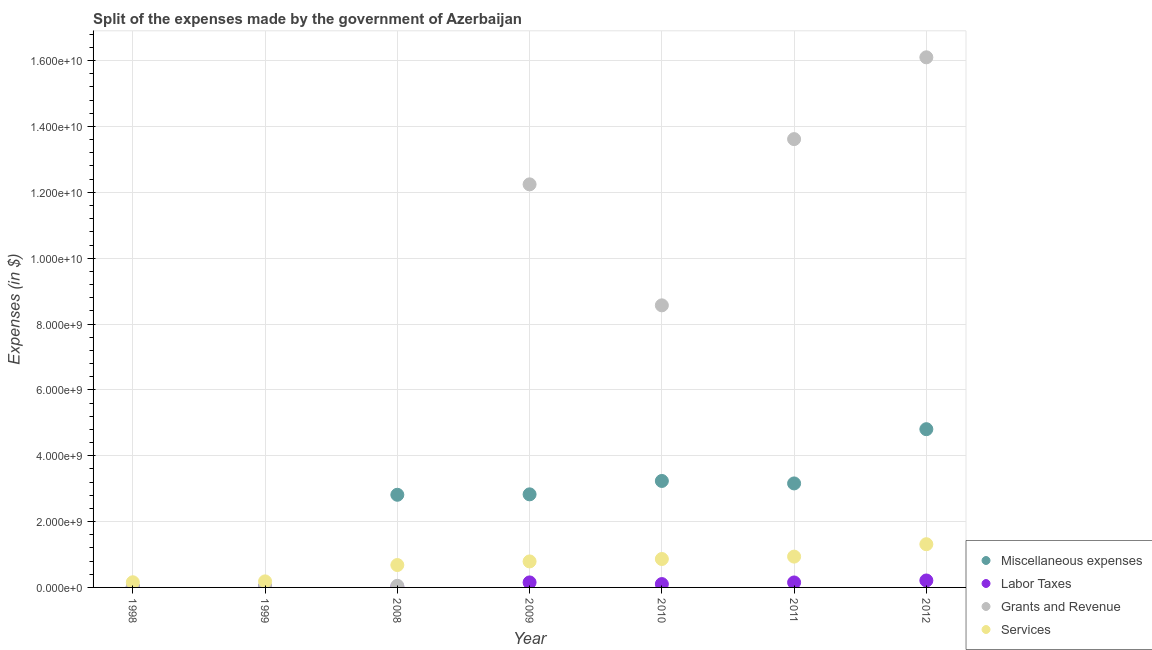What is the amount spent on miscellaneous expenses in 2011?
Offer a very short reply. 3.16e+09. Across all years, what is the maximum amount spent on services?
Your response must be concise. 1.31e+09. Across all years, what is the minimum amount spent on services?
Provide a succinct answer. 1.57e+08. In which year was the amount spent on labor taxes minimum?
Offer a terse response. 1998. What is the total amount spent on labor taxes in the graph?
Make the answer very short. 6.56e+08. What is the difference between the amount spent on services in 1998 and that in 2008?
Give a very brief answer. -5.24e+08. What is the difference between the amount spent on labor taxes in 2011 and the amount spent on grants and revenue in 1998?
Offer a terse response. 1.18e+08. What is the average amount spent on labor taxes per year?
Keep it short and to the point. 9.37e+07. In the year 1998, what is the difference between the amount spent on labor taxes and amount spent on grants and revenue?
Provide a succinct answer. -2.40e+07. What is the ratio of the amount spent on labor taxes in 2008 to that in 2010?
Give a very brief answer. 0.14. Is the difference between the amount spent on services in 2011 and 2012 greater than the difference between the amount spent on grants and revenue in 2011 and 2012?
Give a very brief answer. Yes. What is the difference between the highest and the second highest amount spent on labor taxes?
Provide a succinct answer. 5.88e+07. What is the difference between the highest and the lowest amount spent on miscellaneous expenses?
Your answer should be compact. 4.79e+09. In how many years, is the amount spent on grants and revenue greater than the average amount spent on grants and revenue taken over all years?
Make the answer very short. 4. Is the amount spent on labor taxes strictly greater than the amount spent on services over the years?
Ensure brevity in your answer.  No. How many dotlines are there?
Give a very brief answer. 4. How many years are there in the graph?
Keep it short and to the point. 7. What is the difference between two consecutive major ticks on the Y-axis?
Give a very brief answer. 2.00e+09. Where does the legend appear in the graph?
Offer a very short reply. Bottom right. How are the legend labels stacked?
Offer a very short reply. Vertical. What is the title of the graph?
Keep it short and to the point. Split of the expenses made by the government of Azerbaijan. What is the label or title of the X-axis?
Make the answer very short. Year. What is the label or title of the Y-axis?
Offer a very short reply. Expenses (in $). What is the Expenses (in $) of Miscellaneous expenses in 1998?
Provide a succinct answer. 1.60e+07. What is the Expenses (in $) in Labor Taxes in 1998?
Provide a succinct answer. 8.90e+06. What is the Expenses (in $) in Grants and Revenue in 1998?
Your answer should be very brief. 3.29e+07. What is the Expenses (in $) of Services in 1998?
Keep it short and to the point. 1.57e+08. What is the Expenses (in $) of Miscellaneous expenses in 1999?
Provide a succinct answer. 1.23e+07. What is the Expenses (in $) of Labor Taxes in 1999?
Your response must be concise. 1.66e+07. What is the Expenses (in $) of Grants and Revenue in 1999?
Keep it short and to the point. 4.76e+07. What is the Expenses (in $) in Services in 1999?
Keep it short and to the point. 1.84e+08. What is the Expenses (in $) in Miscellaneous expenses in 2008?
Keep it short and to the point. 2.81e+09. What is the Expenses (in $) of Labor Taxes in 2008?
Offer a very short reply. 1.43e+07. What is the Expenses (in $) of Grants and Revenue in 2008?
Your answer should be very brief. 4.87e+07. What is the Expenses (in $) in Services in 2008?
Make the answer very short. 6.80e+08. What is the Expenses (in $) of Miscellaneous expenses in 2009?
Offer a terse response. 2.83e+09. What is the Expenses (in $) in Labor Taxes in 2009?
Provide a short and direct response. 1.52e+08. What is the Expenses (in $) in Grants and Revenue in 2009?
Keep it short and to the point. 1.22e+1. What is the Expenses (in $) of Services in 2009?
Provide a short and direct response. 7.90e+08. What is the Expenses (in $) of Miscellaneous expenses in 2010?
Provide a succinct answer. 3.23e+09. What is the Expenses (in $) in Labor Taxes in 2010?
Offer a terse response. 1.02e+08. What is the Expenses (in $) in Grants and Revenue in 2010?
Provide a short and direct response. 8.57e+09. What is the Expenses (in $) in Services in 2010?
Offer a terse response. 8.63e+08. What is the Expenses (in $) in Miscellaneous expenses in 2011?
Provide a succinct answer. 3.16e+09. What is the Expenses (in $) of Labor Taxes in 2011?
Your answer should be very brief. 1.51e+08. What is the Expenses (in $) in Grants and Revenue in 2011?
Your response must be concise. 1.36e+1. What is the Expenses (in $) of Services in 2011?
Offer a very short reply. 9.36e+08. What is the Expenses (in $) in Miscellaneous expenses in 2012?
Offer a very short reply. 4.81e+09. What is the Expenses (in $) in Labor Taxes in 2012?
Ensure brevity in your answer.  2.11e+08. What is the Expenses (in $) of Grants and Revenue in 2012?
Keep it short and to the point. 1.61e+1. What is the Expenses (in $) in Services in 2012?
Provide a short and direct response. 1.31e+09. Across all years, what is the maximum Expenses (in $) of Miscellaneous expenses?
Your answer should be compact. 4.81e+09. Across all years, what is the maximum Expenses (in $) in Labor Taxes?
Offer a very short reply. 2.11e+08. Across all years, what is the maximum Expenses (in $) of Grants and Revenue?
Offer a very short reply. 1.61e+1. Across all years, what is the maximum Expenses (in $) of Services?
Ensure brevity in your answer.  1.31e+09. Across all years, what is the minimum Expenses (in $) of Miscellaneous expenses?
Your answer should be very brief. 1.23e+07. Across all years, what is the minimum Expenses (in $) in Labor Taxes?
Keep it short and to the point. 8.90e+06. Across all years, what is the minimum Expenses (in $) of Grants and Revenue?
Your response must be concise. 3.29e+07. Across all years, what is the minimum Expenses (in $) of Services?
Ensure brevity in your answer.  1.57e+08. What is the total Expenses (in $) in Miscellaneous expenses in the graph?
Give a very brief answer. 1.69e+1. What is the total Expenses (in $) of Labor Taxes in the graph?
Your response must be concise. 6.56e+08. What is the total Expenses (in $) in Grants and Revenue in the graph?
Provide a succinct answer. 5.07e+1. What is the total Expenses (in $) of Services in the graph?
Your response must be concise. 4.92e+09. What is the difference between the Expenses (in $) in Miscellaneous expenses in 1998 and that in 1999?
Provide a short and direct response. 3.77e+06. What is the difference between the Expenses (in $) in Labor Taxes in 1998 and that in 1999?
Keep it short and to the point. -7.72e+06. What is the difference between the Expenses (in $) of Grants and Revenue in 1998 and that in 1999?
Ensure brevity in your answer.  -1.47e+07. What is the difference between the Expenses (in $) of Services in 1998 and that in 1999?
Give a very brief answer. -2.69e+07. What is the difference between the Expenses (in $) of Miscellaneous expenses in 1998 and that in 2008?
Your response must be concise. -2.80e+09. What is the difference between the Expenses (in $) of Labor Taxes in 1998 and that in 2008?
Your answer should be compact. -5.36e+06. What is the difference between the Expenses (in $) of Grants and Revenue in 1998 and that in 2008?
Offer a very short reply. -1.58e+07. What is the difference between the Expenses (in $) in Services in 1998 and that in 2008?
Give a very brief answer. -5.24e+08. What is the difference between the Expenses (in $) in Miscellaneous expenses in 1998 and that in 2009?
Provide a short and direct response. -2.81e+09. What is the difference between the Expenses (in $) of Labor Taxes in 1998 and that in 2009?
Make the answer very short. -1.43e+08. What is the difference between the Expenses (in $) of Grants and Revenue in 1998 and that in 2009?
Your answer should be very brief. -1.22e+1. What is the difference between the Expenses (in $) of Services in 1998 and that in 2009?
Your answer should be compact. -6.33e+08. What is the difference between the Expenses (in $) of Miscellaneous expenses in 1998 and that in 2010?
Make the answer very short. -3.22e+09. What is the difference between the Expenses (in $) of Labor Taxes in 1998 and that in 2010?
Your answer should be very brief. -9.28e+07. What is the difference between the Expenses (in $) of Grants and Revenue in 1998 and that in 2010?
Keep it short and to the point. -8.53e+09. What is the difference between the Expenses (in $) of Services in 1998 and that in 2010?
Offer a terse response. -7.06e+08. What is the difference between the Expenses (in $) in Miscellaneous expenses in 1998 and that in 2011?
Provide a short and direct response. -3.14e+09. What is the difference between the Expenses (in $) in Labor Taxes in 1998 and that in 2011?
Your response must be concise. -1.42e+08. What is the difference between the Expenses (in $) of Grants and Revenue in 1998 and that in 2011?
Provide a succinct answer. -1.36e+1. What is the difference between the Expenses (in $) in Services in 1998 and that in 2011?
Your answer should be very brief. -7.79e+08. What is the difference between the Expenses (in $) in Miscellaneous expenses in 1998 and that in 2012?
Offer a terse response. -4.79e+09. What is the difference between the Expenses (in $) of Labor Taxes in 1998 and that in 2012?
Your response must be concise. -2.02e+08. What is the difference between the Expenses (in $) in Grants and Revenue in 1998 and that in 2012?
Your response must be concise. -1.61e+1. What is the difference between the Expenses (in $) in Services in 1998 and that in 2012?
Give a very brief answer. -1.16e+09. What is the difference between the Expenses (in $) of Miscellaneous expenses in 1999 and that in 2008?
Your answer should be compact. -2.80e+09. What is the difference between the Expenses (in $) in Labor Taxes in 1999 and that in 2008?
Give a very brief answer. 2.36e+06. What is the difference between the Expenses (in $) of Grants and Revenue in 1999 and that in 2008?
Ensure brevity in your answer.  -1.16e+06. What is the difference between the Expenses (in $) in Services in 1999 and that in 2008?
Provide a short and direct response. -4.97e+08. What is the difference between the Expenses (in $) of Miscellaneous expenses in 1999 and that in 2009?
Provide a succinct answer. -2.81e+09. What is the difference between the Expenses (in $) of Labor Taxes in 1999 and that in 2009?
Ensure brevity in your answer.  -1.36e+08. What is the difference between the Expenses (in $) in Grants and Revenue in 1999 and that in 2009?
Give a very brief answer. -1.22e+1. What is the difference between the Expenses (in $) in Services in 1999 and that in 2009?
Offer a terse response. -6.06e+08. What is the difference between the Expenses (in $) in Miscellaneous expenses in 1999 and that in 2010?
Your answer should be compact. -3.22e+09. What is the difference between the Expenses (in $) of Labor Taxes in 1999 and that in 2010?
Provide a short and direct response. -8.51e+07. What is the difference between the Expenses (in $) of Grants and Revenue in 1999 and that in 2010?
Keep it short and to the point. -8.52e+09. What is the difference between the Expenses (in $) of Services in 1999 and that in 2010?
Your answer should be compact. -6.79e+08. What is the difference between the Expenses (in $) of Miscellaneous expenses in 1999 and that in 2011?
Your answer should be compact. -3.15e+09. What is the difference between the Expenses (in $) of Labor Taxes in 1999 and that in 2011?
Provide a short and direct response. -1.34e+08. What is the difference between the Expenses (in $) of Grants and Revenue in 1999 and that in 2011?
Keep it short and to the point. -1.36e+1. What is the difference between the Expenses (in $) in Services in 1999 and that in 2011?
Provide a short and direct response. -7.52e+08. What is the difference between the Expenses (in $) of Miscellaneous expenses in 1999 and that in 2012?
Provide a short and direct response. -4.79e+09. What is the difference between the Expenses (in $) in Labor Taxes in 1999 and that in 2012?
Provide a short and direct response. -1.94e+08. What is the difference between the Expenses (in $) of Grants and Revenue in 1999 and that in 2012?
Keep it short and to the point. -1.61e+1. What is the difference between the Expenses (in $) of Services in 1999 and that in 2012?
Keep it short and to the point. -1.13e+09. What is the difference between the Expenses (in $) in Miscellaneous expenses in 2008 and that in 2009?
Provide a short and direct response. -1.29e+07. What is the difference between the Expenses (in $) of Labor Taxes in 2008 and that in 2009?
Offer a very short reply. -1.38e+08. What is the difference between the Expenses (in $) in Grants and Revenue in 2008 and that in 2009?
Your answer should be very brief. -1.22e+1. What is the difference between the Expenses (in $) of Services in 2008 and that in 2009?
Give a very brief answer. -1.09e+08. What is the difference between the Expenses (in $) of Miscellaneous expenses in 2008 and that in 2010?
Provide a succinct answer. -4.19e+08. What is the difference between the Expenses (in $) of Labor Taxes in 2008 and that in 2010?
Provide a short and direct response. -8.74e+07. What is the difference between the Expenses (in $) of Grants and Revenue in 2008 and that in 2010?
Offer a terse response. -8.52e+09. What is the difference between the Expenses (in $) in Services in 2008 and that in 2010?
Your answer should be very brief. -1.83e+08. What is the difference between the Expenses (in $) of Miscellaneous expenses in 2008 and that in 2011?
Your response must be concise. -3.45e+08. What is the difference between the Expenses (in $) of Labor Taxes in 2008 and that in 2011?
Offer a terse response. -1.37e+08. What is the difference between the Expenses (in $) of Grants and Revenue in 2008 and that in 2011?
Offer a terse response. -1.36e+1. What is the difference between the Expenses (in $) in Services in 2008 and that in 2011?
Keep it short and to the point. -2.56e+08. What is the difference between the Expenses (in $) of Miscellaneous expenses in 2008 and that in 2012?
Your answer should be very brief. -1.99e+09. What is the difference between the Expenses (in $) of Labor Taxes in 2008 and that in 2012?
Your answer should be very brief. -1.97e+08. What is the difference between the Expenses (in $) in Grants and Revenue in 2008 and that in 2012?
Your response must be concise. -1.61e+1. What is the difference between the Expenses (in $) of Services in 2008 and that in 2012?
Keep it short and to the point. -6.32e+08. What is the difference between the Expenses (in $) in Miscellaneous expenses in 2009 and that in 2010?
Give a very brief answer. -4.06e+08. What is the difference between the Expenses (in $) of Labor Taxes in 2009 and that in 2010?
Ensure brevity in your answer.  5.05e+07. What is the difference between the Expenses (in $) in Grants and Revenue in 2009 and that in 2010?
Give a very brief answer. 3.67e+09. What is the difference between the Expenses (in $) of Services in 2009 and that in 2010?
Ensure brevity in your answer.  -7.34e+07. What is the difference between the Expenses (in $) of Miscellaneous expenses in 2009 and that in 2011?
Your answer should be very brief. -3.32e+08. What is the difference between the Expenses (in $) in Labor Taxes in 2009 and that in 2011?
Your answer should be very brief. 1.30e+06. What is the difference between the Expenses (in $) in Grants and Revenue in 2009 and that in 2011?
Provide a short and direct response. -1.37e+09. What is the difference between the Expenses (in $) in Services in 2009 and that in 2011?
Keep it short and to the point. -1.46e+08. What is the difference between the Expenses (in $) of Miscellaneous expenses in 2009 and that in 2012?
Offer a terse response. -1.98e+09. What is the difference between the Expenses (in $) of Labor Taxes in 2009 and that in 2012?
Make the answer very short. -5.88e+07. What is the difference between the Expenses (in $) in Grants and Revenue in 2009 and that in 2012?
Ensure brevity in your answer.  -3.86e+09. What is the difference between the Expenses (in $) in Services in 2009 and that in 2012?
Provide a short and direct response. -5.23e+08. What is the difference between the Expenses (in $) of Miscellaneous expenses in 2010 and that in 2011?
Offer a terse response. 7.48e+07. What is the difference between the Expenses (in $) of Labor Taxes in 2010 and that in 2011?
Offer a terse response. -4.92e+07. What is the difference between the Expenses (in $) of Grants and Revenue in 2010 and that in 2011?
Your response must be concise. -5.05e+09. What is the difference between the Expenses (in $) in Services in 2010 and that in 2011?
Give a very brief answer. -7.29e+07. What is the difference between the Expenses (in $) of Miscellaneous expenses in 2010 and that in 2012?
Ensure brevity in your answer.  -1.57e+09. What is the difference between the Expenses (in $) of Labor Taxes in 2010 and that in 2012?
Ensure brevity in your answer.  -1.09e+08. What is the difference between the Expenses (in $) in Grants and Revenue in 2010 and that in 2012?
Make the answer very short. -7.53e+09. What is the difference between the Expenses (in $) in Services in 2010 and that in 2012?
Keep it short and to the point. -4.49e+08. What is the difference between the Expenses (in $) in Miscellaneous expenses in 2011 and that in 2012?
Ensure brevity in your answer.  -1.65e+09. What is the difference between the Expenses (in $) of Labor Taxes in 2011 and that in 2012?
Make the answer very short. -6.01e+07. What is the difference between the Expenses (in $) of Grants and Revenue in 2011 and that in 2012?
Provide a short and direct response. -2.48e+09. What is the difference between the Expenses (in $) in Services in 2011 and that in 2012?
Provide a succinct answer. -3.76e+08. What is the difference between the Expenses (in $) in Miscellaneous expenses in 1998 and the Expenses (in $) in Labor Taxes in 1999?
Your answer should be very brief. -5.70e+05. What is the difference between the Expenses (in $) of Miscellaneous expenses in 1998 and the Expenses (in $) of Grants and Revenue in 1999?
Your answer should be very brief. -3.15e+07. What is the difference between the Expenses (in $) of Miscellaneous expenses in 1998 and the Expenses (in $) of Services in 1999?
Provide a short and direct response. -1.68e+08. What is the difference between the Expenses (in $) of Labor Taxes in 1998 and the Expenses (in $) of Grants and Revenue in 1999?
Provide a short and direct response. -3.87e+07. What is the difference between the Expenses (in $) in Labor Taxes in 1998 and the Expenses (in $) in Services in 1999?
Make the answer very short. -1.75e+08. What is the difference between the Expenses (in $) in Grants and Revenue in 1998 and the Expenses (in $) in Services in 1999?
Your answer should be very brief. -1.51e+08. What is the difference between the Expenses (in $) of Miscellaneous expenses in 1998 and the Expenses (in $) of Labor Taxes in 2008?
Provide a short and direct response. 1.79e+06. What is the difference between the Expenses (in $) in Miscellaneous expenses in 1998 and the Expenses (in $) in Grants and Revenue in 2008?
Offer a terse response. -3.27e+07. What is the difference between the Expenses (in $) in Miscellaneous expenses in 1998 and the Expenses (in $) in Services in 2008?
Make the answer very short. -6.64e+08. What is the difference between the Expenses (in $) of Labor Taxes in 1998 and the Expenses (in $) of Grants and Revenue in 2008?
Your answer should be compact. -3.98e+07. What is the difference between the Expenses (in $) in Labor Taxes in 1998 and the Expenses (in $) in Services in 2008?
Keep it short and to the point. -6.72e+08. What is the difference between the Expenses (in $) of Grants and Revenue in 1998 and the Expenses (in $) of Services in 2008?
Provide a succinct answer. -6.48e+08. What is the difference between the Expenses (in $) in Miscellaneous expenses in 1998 and the Expenses (in $) in Labor Taxes in 2009?
Keep it short and to the point. -1.36e+08. What is the difference between the Expenses (in $) in Miscellaneous expenses in 1998 and the Expenses (in $) in Grants and Revenue in 2009?
Provide a short and direct response. -1.22e+1. What is the difference between the Expenses (in $) of Miscellaneous expenses in 1998 and the Expenses (in $) of Services in 2009?
Keep it short and to the point. -7.74e+08. What is the difference between the Expenses (in $) of Labor Taxes in 1998 and the Expenses (in $) of Grants and Revenue in 2009?
Offer a terse response. -1.22e+1. What is the difference between the Expenses (in $) in Labor Taxes in 1998 and the Expenses (in $) in Services in 2009?
Make the answer very short. -7.81e+08. What is the difference between the Expenses (in $) in Grants and Revenue in 1998 and the Expenses (in $) in Services in 2009?
Offer a very short reply. -7.57e+08. What is the difference between the Expenses (in $) of Miscellaneous expenses in 1998 and the Expenses (in $) of Labor Taxes in 2010?
Give a very brief answer. -8.57e+07. What is the difference between the Expenses (in $) in Miscellaneous expenses in 1998 and the Expenses (in $) in Grants and Revenue in 2010?
Your response must be concise. -8.55e+09. What is the difference between the Expenses (in $) in Miscellaneous expenses in 1998 and the Expenses (in $) in Services in 2010?
Provide a succinct answer. -8.47e+08. What is the difference between the Expenses (in $) in Labor Taxes in 1998 and the Expenses (in $) in Grants and Revenue in 2010?
Your answer should be compact. -8.56e+09. What is the difference between the Expenses (in $) of Labor Taxes in 1998 and the Expenses (in $) of Services in 2010?
Your response must be concise. -8.54e+08. What is the difference between the Expenses (in $) in Grants and Revenue in 1998 and the Expenses (in $) in Services in 2010?
Ensure brevity in your answer.  -8.30e+08. What is the difference between the Expenses (in $) of Miscellaneous expenses in 1998 and the Expenses (in $) of Labor Taxes in 2011?
Your response must be concise. -1.35e+08. What is the difference between the Expenses (in $) in Miscellaneous expenses in 1998 and the Expenses (in $) in Grants and Revenue in 2011?
Your response must be concise. -1.36e+1. What is the difference between the Expenses (in $) in Miscellaneous expenses in 1998 and the Expenses (in $) in Services in 2011?
Your response must be concise. -9.20e+08. What is the difference between the Expenses (in $) in Labor Taxes in 1998 and the Expenses (in $) in Grants and Revenue in 2011?
Provide a succinct answer. -1.36e+1. What is the difference between the Expenses (in $) of Labor Taxes in 1998 and the Expenses (in $) of Services in 2011?
Offer a very short reply. -9.27e+08. What is the difference between the Expenses (in $) of Grants and Revenue in 1998 and the Expenses (in $) of Services in 2011?
Provide a succinct answer. -9.03e+08. What is the difference between the Expenses (in $) in Miscellaneous expenses in 1998 and the Expenses (in $) in Labor Taxes in 2012?
Ensure brevity in your answer.  -1.95e+08. What is the difference between the Expenses (in $) in Miscellaneous expenses in 1998 and the Expenses (in $) in Grants and Revenue in 2012?
Provide a short and direct response. -1.61e+1. What is the difference between the Expenses (in $) of Miscellaneous expenses in 1998 and the Expenses (in $) of Services in 2012?
Offer a terse response. -1.30e+09. What is the difference between the Expenses (in $) of Labor Taxes in 1998 and the Expenses (in $) of Grants and Revenue in 2012?
Provide a succinct answer. -1.61e+1. What is the difference between the Expenses (in $) in Labor Taxes in 1998 and the Expenses (in $) in Services in 2012?
Provide a succinct answer. -1.30e+09. What is the difference between the Expenses (in $) of Grants and Revenue in 1998 and the Expenses (in $) of Services in 2012?
Ensure brevity in your answer.  -1.28e+09. What is the difference between the Expenses (in $) of Miscellaneous expenses in 1999 and the Expenses (in $) of Labor Taxes in 2008?
Provide a short and direct response. -1.98e+06. What is the difference between the Expenses (in $) of Miscellaneous expenses in 1999 and the Expenses (in $) of Grants and Revenue in 2008?
Make the answer very short. -3.65e+07. What is the difference between the Expenses (in $) of Miscellaneous expenses in 1999 and the Expenses (in $) of Services in 2008?
Ensure brevity in your answer.  -6.68e+08. What is the difference between the Expenses (in $) of Labor Taxes in 1999 and the Expenses (in $) of Grants and Revenue in 2008?
Give a very brief answer. -3.21e+07. What is the difference between the Expenses (in $) of Labor Taxes in 1999 and the Expenses (in $) of Services in 2008?
Give a very brief answer. -6.64e+08. What is the difference between the Expenses (in $) in Grants and Revenue in 1999 and the Expenses (in $) in Services in 2008?
Your answer should be very brief. -6.33e+08. What is the difference between the Expenses (in $) of Miscellaneous expenses in 1999 and the Expenses (in $) of Labor Taxes in 2009?
Offer a very short reply. -1.40e+08. What is the difference between the Expenses (in $) of Miscellaneous expenses in 1999 and the Expenses (in $) of Grants and Revenue in 2009?
Your answer should be compact. -1.22e+1. What is the difference between the Expenses (in $) of Miscellaneous expenses in 1999 and the Expenses (in $) of Services in 2009?
Your response must be concise. -7.78e+08. What is the difference between the Expenses (in $) of Labor Taxes in 1999 and the Expenses (in $) of Grants and Revenue in 2009?
Make the answer very short. -1.22e+1. What is the difference between the Expenses (in $) in Labor Taxes in 1999 and the Expenses (in $) in Services in 2009?
Offer a terse response. -7.73e+08. What is the difference between the Expenses (in $) in Grants and Revenue in 1999 and the Expenses (in $) in Services in 2009?
Offer a very short reply. -7.42e+08. What is the difference between the Expenses (in $) in Miscellaneous expenses in 1999 and the Expenses (in $) in Labor Taxes in 2010?
Provide a short and direct response. -8.94e+07. What is the difference between the Expenses (in $) in Miscellaneous expenses in 1999 and the Expenses (in $) in Grants and Revenue in 2010?
Ensure brevity in your answer.  -8.56e+09. What is the difference between the Expenses (in $) in Miscellaneous expenses in 1999 and the Expenses (in $) in Services in 2010?
Provide a short and direct response. -8.51e+08. What is the difference between the Expenses (in $) of Labor Taxes in 1999 and the Expenses (in $) of Grants and Revenue in 2010?
Your answer should be compact. -8.55e+09. What is the difference between the Expenses (in $) of Labor Taxes in 1999 and the Expenses (in $) of Services in 2010?
Ensure brevity in your answer.  -8.47e+08. What is the difference between the Expenses (in $) of Grants and Revenue in 1999 and the Expenses (in $) of Services in 2010?
Offer a terse response. -8.16e+08. What is the difference between the Expenses (in $) in Miscellaneous expenses in 1999 and the Expenses (in $) in Labor Taxes in 2011?
Offer a terse response. -1.39e+08. What is the difference between the Expenses (in $) of Miscellaneous expenses in 1999 and the Expenses (in $) of Grants and Revenue in 2011?
Provide a succinct answer. -1.36e+1. What is the difference between the Expenses (in $) of Miscellaneous expenses in 1999 and the Expenses (in $) of Services in 2011?
Offer a terse response. -9.24e+08. What is the difference between the Expenses (in $) in Labor Taxes in 1999 and the Expenses (in $) in Grants and Revenue in 2011?
Provide a succinct answer. -1.36e+1. What is the difference between the Expenses (in $) in Labor Taxes in 1999 and the Expenses (in $) in Services in 2011?
Your answer should be very brief. -9.19e+08. What is the difference between the Expenses (in $) of Grants and Revenue in 1999 and the Expenses (in $) of Services in 2011?
Provide a short and direct response. -8.89e+08. What is the difference between the Expenses (in $) in Miscellaneous expenses in 1999 and the Expenses (in $) in Labor Taxes in 2012?
Provide a succinct answer. -1.99e+08. What is the difference between the Expenses (in $) of Miscellaneous expenses in 1999 and the Expenses (in $) of Grants and Revenue in 2012?
Offer a very short reply. -1.61e+1. What is the difference between the Expenses (in $) of Miscellaneous expenses in 1999 and the Expenses (in $) of Services in 2012?
Ensure brevity in your answer.  -1.30e+09. What is the difference between the Expenses (in $) of Labor Taxes in 1999 and the Expenses (in $) of Grants and Revenue in 2012?
Ensure brevity in your answer.  -1.61e+1. What is the difference between the Expenses (in $) in Labor Taxes in 1999 and the Expenses (in $) in Services in 2012?
Your answer should be very brief. -1.30e+09. What is the difference between the Expenses (in $) in Grants and Revenue in 1999 and the Expenses (in $) in Services in 2012?
Offer a very short reply. -1.26e+09. What is the difference between the Expenses (in $) in Miscellaneous expenses in 2008 and the Expenses (in $) in Labor Taxes in 2009?
Provide a succinct answer. 2.66e+09. What is the difference between the Expenses (in $) in Miscellaneous expenses in 2008 and the Expenses (in $) in Grants and Revenue in 2009?
Provide a succinct answer. -9.43e+09. What is the difference between the Expenses (in $) in Miscellaneous expenses in 2008 and the Expenses (in $) in Services in 2009?
Your answer should be compact. 2.02e+09. What is the difference between the Expenses (in $) of Labor Taxes in 2008 and the Expenses (in $) of Grants and Revenue in 2009?
Your response must be concise. -1.22e+1. What is the difference between the Expenses (in $) in Labor Taxes in 2008 and the Expenses (in $) in Services in 2009?
Offer a very short reply. -7.76e+08. What is the difference between the Expenses (in $) of Grants and Revenue in 2008 and the Expenses (in $) of Services in 2009?
Provide a succinct answer. -7.41e+08. What is the difference between the Expenses (in $) in Miscellaneous expenses in 2008 and the Expenses (in $) in Labor Taxes in 2010?
Ensure brevity in your answer.  2.71e+09. What is the difference between the Expenses (in $) of Miscellaneous expenses in 2008 and the Expenses (in $) of Grants and Revenue in 2010?
Give a very brief answer. -5.75e+09. What is the difference between the Expenses (in $) of Miscellaneous expenses in 2008 and the Expenses (in $) of Services in 2010?
Ensure brevity in your answer.  1.95e+09. What is the difference between the Expenses (in $) of Labor Taxes in 2008 and the Expenses (in $) of Grants and Revenue in 2010?
Provide a succinct answer. -8.55e+09. What is the difference between the Expenses (in $) of Labor Taxes in 2008 and the Expenses (in $) of Services in 2010?
Your answer should be compact. -8.49e+08. What is the difference between the Expenses (in $) in Grants and Revenue in 2008 and the Expenses (in $) in Services in 2010?
Keep it short and to the point. -8.14e+08. What is the difference between the Expenses (in $) in Miscellaneous expenses in 2008 and the Expenses (in $) in Labor Taxes in 2011?
Your response must be concise. 2.66e+09. What is the difference between the Expenses (in $) of Miscellaneous expenses in 2008 and the Expenses (in $) of Grants and Revenue in 2011?
Your answer should be compact. -1.08e+1. What is the difference between the Expenses (in $) of Miscellaneous expenses in 2008 and the Expenses (in $) of Services in 2011?
Your response must be concise. 1.88e+09. What is the difference between the Expenses (in $) of Labor Taxes in 2008 and the Expenses (in $) of Grants and Revenue in 2011?
Make the answer very short. -1.36e+1. What is the difference between the Expenses (in $) in Labor Taxes in 2008 and the Expenses (in $) in Services in 2011?
Provide a succinct answer. -9.22e+08. What is the difference between the Expenses (in $) in Grants and Revenue in 2008 and the Expenses (in $) in Services in 2011?
Ensure brevity in your answer.  -8.87e+08. What is the difference between the Expenses (in $) of Miscellaneous expenses in 2008 and the Expenses (in $) of Labor Taxes in 2012?
Ensure brevity in your answer.  2.60e+09. What is the difference between the Expenses (in $) in Miscellaneous expenses in 2008 and the Expenses (in $) in Grants and Revenue in 2012?
Keep it short and to the point. -1.33e+1. What is the difference between the Expenses (in $) in Miscellaneous expenses in 2008 and the Expenses (in $) in Services in 2012?
Provide a succinct answer. 1.50e+09. What is the difference between the Expenses (in $) of Labor Taxes in 2008 and the Expenses (in $) of Grants and Revenue in 2012?
Offer a very short reply. -1.61e+1. What is the difference between the Expenses (in $) in Labor Taxes in 2008 and the Expenses (in $) in Services in 2012?
Your answer should be very brief. -1.30e+09. What is the difference between the Expenses (in $) in Grants and Revenue in 2008 and the Expenses (in $) in Services in 2012?
Offer a terse response. -1.26e+09. What is the difference between the Expenses (in $) of Miscellaneous expenses in 2009 and the Expenses (in $) of Labor Taxes in 2010?
Offer a very short reply. 2.73e+09. What is the difference between the Expenses (in $) in Miscellaneous expenses in 2009 and the Expenses (in $) in Grants and Revenue in 2010?
Offer a terse response. -5.74e+09. What is the difference between the Expenses (in $) of Miscellaneous expenses in 2009 and the Expenses (in $) of Services in 2010?
Offer a terse response. 1.96e+09. What is the difference between the Expenses (in $) of Labor Taxes in 2009 and the Expenses (in $) of Grants and Revenue in 2010?
Your response must be concise. -8.42e+09. What is the difference between the Expenses (in $) in Labor Taxes in 2009 and the Expenses (in $) in Services in 2010?
Your response must be concise. -7.11e+08. What is the difference between the Expenses (in $) in Grants and Revenue in 2009 and the Expenses (in $) in Services in 2010?
Your response must be concise. 1.14e+1. What is the difference between the Expenses (in $) of Miscellaneous expenses in 2009 and the Expenses (in $) of Labor Taxes in 2011?
Give a very brief answer. 2.68e+09. What is the difference between the Expenses (in $) of Miscellaneous expenses in 2009 and the Expenses (in $) of Grants and Revenue in 2011?
Ensure brevity in your answer.  -1.08e+1. What is the difference between the Expenses (in $) in Miscellaneous expenses in 2009 and the Expenses (in $) in Services in 2011?
Provide a succinct answer. 1.89e+09. What is the difference between the Expenses (in $) of Labor Taxes in 2009 and the Expenses (in $) of Grants and Revenue in 2011?
Your answer should be very brief. -1.35e+1. What is the difference between the Expenses (in $) of Labor Taxes in 2009 and the Expenses (in $) of Services in 2011?
Your response must be concise. -7.84e+08. What is the difference between the Expenses (in $) of Grants and Revenue in 2009 and the Expenses (in $) of Services in 2011?
Your answer should be very brief. 1.13e+1. What is the difference between the Expenses (in $) of Miscellaneous expenses in 2009 and the Expenses (in $) of Labor Taxes in 2012?
Your answer should be compact. 2.62e+09. What is the difference between the Expenses (in $) in Miscellaneous expenses in 2009 and the Expenses (in $) in Grants and Revenue in 2012?
Your answer should be compact. -1.33e+1. What is the difference between the Expenses (in $) in Miscellaneous expenses in 2009 and the Expenses (in $) in Services in 2012?
Your answer should be compact. 1.51e+09. What is the difference between the Expenses (in $) of Labor Taxes in 2009 and the Expenses (in $) of Grants and Revenue in 2012?
Your answer should be very brief. -1.59e+1. What is the difference between the Expenses (in $) in Labor Taxes in 2009 and the Expenses (in $) in Services in 2012?
Offer a very short reply. -1.16e+09. What is the difference between the Expenses (in $) of Grants and Revenue in 2009 and the Expenses (in $) of Services in 2012?
Provide a succinct answer. 1.09e+1. What is the difference between the Expenses (in $) of Miscellaneous expenses in 2010 and the Expenses (in $) of Labor Taxes in 2011?
Make the answer very short. 3.08e+09. What is the difference between the Expenses (in $) of Miscellaneous expenses in 2010 and the Expenses (in $) of Grants and Revenue in 2011?
Offer a terse response. -1.04e+1. What is the difference between the Expenses (in $) in Miscellaneous expenses in 2010 and the Expenses (in $) in Services in 2011?
Your answer should be very brief. 2.30e+09. What is the difference between the Expenses (in $) in Labor Taxes in 2010 and the Expenses (in $) in Grants and Revenue in 2011?
Your response must be concise. -1.35e+1. What is the difference between the Expenses (in $) in Labor Taxes in 2010 and the Expenses (in $) in Services in 2011?
Your answer should be compact. -8.34e+08. What is the difference between the Expenses (in $) of Grants and Revenue in 2010 and the Expenses (in $) of Services in 2011?
Make the answer very short. 7.63e+09. What is the difference between the Expenses (in $) in Miscellaneous expenses in 2010 and the Expenses (in $) in Labor Taxes in 2012?
Offer a terse response. 3.02e+09. What is the difference between the Expenses (in $) of Miscellaneous expenses in 2010 and the Expenses (in $) of Grants and Revenue in 2012?
Your answer should be compact. -1.29e+1. What is the difference between the Expenses (in $) in Miscellaneous expenses in 2010 and the Expenses (in $) in Services in 2012?
Offer a very short reply. 1.92e+09. What is the difference between the Expenses (in $) in Labor Taxes in 2010 and the Expenses (in $) in Grants and Revenue in 2012?
Your answer should be very brief. -1.60e+1. What is the difference between the Expenses (in $) in Labor Taxes in 2010 and the Expenses (in $) in Services in 2012?
Give a very brief answer. -1.21e+09. What is the difference between the Expenses (in $) of Grants and Revenue in 2010 and the Expenses (in $) of Services in 2012?
Ensure brevity in your answer.  7.25e+09. What is the difference between the Expenses (in $) of Miscellaneous expenses in 2011 and the Expenses (in $) of Labor Taxes in 2012?
Your answer should be compact. 2.95e+09. What is the difference between the Expenses (in $) of Miscellaneous expenses in 2011 and the Expenses (in $) of Grants and Revenue in 2012?
Make the answer very short. -1.29e+1. What is the difference between the Expenses (in $) in Miscellaneous expenses in 2011 and the Expenses (in $) in Services in 2012?
Make the answer very short. 1.85e+09. What is the difference between the Expenses (in $) of Labor Taxes in 2011 and the Expenses (in $) of Grants and Revenue in 2012?
Give a very brief answer. -1.59e+1. What is the difference between the Expenses (in $) in Labor Taxes in 2011 and the Expenses (in $) in Services in 2012?
Offer a very short reply. -1.16e+09. What is the difference between the Expenses (in $) in Grants and Revenue in 2011 and the Expenses (in $) in Services in 2012?
Your response must be concise. 1.23e+1. What is the average Expenses (in $) in Miscellaneous expenses per year?
Offer a terse response. 2.41e+09. What is the average Expenses (in $) of Labor Taxes per year?
Provide a succinct answer. 9.37e+07. What is the average Expenses (in $) in Grants and Revenue per year?
Offer a very short reply. 7.24e+09. What is the average Expenses (in $) of Services per year?
Your answer should be compact. 7.03e+08. In the year 1998, what is the difference between the Expenses (in $) of Miscellaneous expenses and Expenses (in $) of Labor Taxes?
Ensure brevity in your answer.  7.14e+06. In the year 1998, what is the difference between the Expenses (in $) in Miscellaneous expenses and Expenses (in $) in Grants and Revenue?
Your answer should be compact. -1.68e+07. In the year 1998, what is the difference between the Expenses (in $) in Miscellaneous expenses and Expenses (in $) in Services?
Offer a terse response. -1.41e+08. In the year 1998, what is the difference between the Expenses (in $) of Labor Taxes and Expenses (in $) of Grants and Revenue?
Make the answer very short. -2.40e+07. In the year 1998, what is the difference between the Expenses (in $) in Labor Taxes and Expenses (in $) in Services?
Give a very brief answer. -1.48e+08. In the year 1998, what is the difference between the Expenses (in $) of Grants and Revenue and Expenses (in $) of Services?
Your answer should be very brief. -1.24e+08. In the year 1999, what is the difference between the Expenses (in $) in Miscellaneous expenses and Expenses (in $) in Labor Taxes?
Make the answer very short. -4.34e+06. In the year 1999, what is the difference between the Expenses (in $) of Miscellaneous expenses and Expenses (in $) of Grants and Revenue?
Ensure brevity in your answer.  -3.53e+07. In the year 1999, what is the difference between the Expenses (in $) of Miscellaneous expenses and Expenses (in $) of Services?
Offer a very short reply. -1.71e+08. In the year 1999, what is the difference between the Expenses (in $) of Labor Taxes and Expenses (in $) of Grants and Revenue?
Ensure brevity in your answer.  -3.10e+07. In the year 1999, what is the difference between the Expenses (in $) of Labor Taxes and Expenses (in $) of Services?
Your answer should be compact. -1.67e+08. In the year 1999, what is the difference between the Expenses (in $) of Grants and Revenue and Expenses (in $) of Services?
Provide a succinct answer. -1.36e+08. In the year 2008, what is the difference between the Expenses (in $) in Miscellaneous expenses and Expenses (in $) in Labor Taxes?
Make the answer very short. 2.80e+09. In the year 2008, what is the difference between the Expenses (in $) of Miscellaneous expenses and Expenses (in $) of Grants and Revenue?
Offer a terse response. 2.77e+09. In the year 2008, what is the difference between the Expenses (in $) in Miscellaneous expenses and Expenses (in $) in Services?
Your answer should be compact. 2.13e+09. In the year 2008, what is the difference between the Expenses (in $) of Labor Taxes and Expenses (in $) of Grants and Revenue?
Make the answer very short. -3.45e+07. In the year 2008, what is the difference between the Expenses (in $) of Labor Taxes and Expenses (in $) of Services?
Offer a very short reply. -6.66e+08. In the year 2008, what is the difference between the Expenses (in $) of Grants and Revenue and Expenses (in $) of Services?
Ensure brevity in your answer.  -6.32e+08. In the year 2009, what is the difference between the Expenses (in $) in Miscellaneous expenses and Expenses (in $) in Labor Taxes?
Offer a terse response. 2.67e+09. In the year 2009, what is the difference between the Expenses (in $) in Miscellaneous expenses and Expenses (in $) in Grants and Revenue?
Your answer should be compact. -9.42e+09. In the year 2009, what is the difference between the Expenses (in $) of Miscellaneous expenses and Expenses (in $) of Services?
Make the answer very short. 2.04e+09. In the year 2009, what is the difference between the Expenses (in $) of Labor Taxes and Expenses (in $) of Grants and Revenue?
Your answer should be compact. -1.21e+1. In the year 2009, what is the difference between the Expenses (in $) in Labor Taxes and Expenses (in $) in Services?
Your answer should be very brief. -6.38e+08. In the year 2009, what is the difference between the Expenses (in $) of Grants and Revenue and Expenses (in $) of Services?
Provide a succinct answer. 1.15e+1. In the year 2010, what is the difference between the Expenses (in $) in Miscellaneous expenses and Expenses (in $) in Labor Taxes?
Make the answer very short. 3.13e+09. In the year 2010, what is the difference between the Expenses (in $) in Miscellaneous expenses and Expenses (in $) in Grants and Revenue?
Give a very brief answer. -5.33e+09. In the year 2010, what is the difference between the Expenses (in $) in Miscellaneous expenses and Expenses (in $) in Services?
Provide a succinct answer. 2.37e+09. In the year 2010, what is the difference between the Expenses (in $) of Labor Taxes and Expenses (in $) of Grants and Revenue?
Offer a terse response. -8.47e+09. In the year 2010, what is the difference between the Expenses (in $) of Labor Taxes and Expenses (in $) of Services?
Offer a very short reply. -7.62e+08. In the year 2010, what is the difference between the Expenses (in $) of Grants and Revenue and Expenses (in $) of Services?
Your answer should be very brief. 7.70e+09. In the year 2011, what is the difference between the Expenses (in $) in Miscellaneous expenses and Expenses (in $) in Labor Taxes?
Provide a short and direct response. 3.01e+09. In the year 2011, what is the difference between the Expenses (in $) of Miscellaneous expenses and Expenses (in $) of Grants and Revenue?
Ensure brevity in your answer.  -1.05e+1. In the year 2011, what is the difference between the Expenses (in $) of Miscellaneous expenses and Expenses (in $) of Services?
Offer a terse response. 2.22e+09. In the year 2011, what is the difference between the Expenses (in $) in Labor Taxes and Expenses (in $) in Grants and Revenue?
Your answer should be compact. -1.35e+1. In the year 2011, what is the difference between the Expenses (in $) in Labor Taxes and Expenses (in $) in Services?
Offer a terse response. -7.85e+08. In the year 2011, what is the difference between the Expenses (in $) in Grants and Revenue and Expenses (in $) in Services?
Your response must be concise. 1.27e+1. In the year 2012, what is the difference between the Expenses (in $) of Miscellaneous expenses and Expenses (in $) of Labor Taxes?
Keep it short and to the point. 4.60e+09. In the year 2012, what is the difference between the Expenses (in $) in Miscellaneous expenses and Expenses (in $) in Grants and Revenue?
Offer a very short reply. -1.13e+1. In the year 2012, what is the difference between the Expenses (in $) of Miscellaneous expenses and Expenses (in $) of Services?
Provide a short and direct response. 3.49e+09. In the year 2012, what is the difference between the Expenses (in $) of Labor Taxes and Expenses (in $) of Grants and Revenue?
Keep it short and to the point. -1.59e+1. In the year 2012, what is the difference between the Expenses (in $) in Labor Taxes and Expenses (in $) in Services?
Your answer should be compact. -1.10e+09. In the year 2012, what is the difference between the Expenses (in $) of Grants and Revenue and Expenses (in $) of Services?
Make the answer very short. 1.48e+1. What is the ratio of the Expenses (in $) of Miscellaneous expenses in 1998 to that in 1999?
Offer a very short reply. 1.31. What is the ratio of the Expenses (in $) in Labor Taxes in 1998 to that in 1999?
Your response must be concise. 0.54. What is the ratio of the Expenses (in $) of Grants and Revenue in 1998 to that in 1999?
Make the answer very short. 0.69. What is the ratio of the Expenses (in $) of Services in 1998 to that in 1999?
Provide a short and direct response. 0.85. What is the ratio of the Expenses (in $) of Miscellaneous expenses in 1998 to that in 2008?
Your answer should be very brief. 0.01. What is the ratio of the Expenses (in $) in Labor Taxes in 1998 to that in 2008?
Provide a succinct answer. 0.62. What is the ratio of the Expenses (in $) in Grants and Revenue in 1998 to that in 2008?
Make the answer very short. 0.68. What is the ratio of the Expenses (in $) of Services in 1998 to that in 2008?
Keep it short and to the point. 0.23. What is the ratio of the Expenses (in $) of Miscellaneous expenses in 1998 to that in 2009?
Make the answer very short. 0.01. What is the ratio of the Expenses (in $) of Labor Taxes in 1998 to that in 2009?
Offer a very short reply. 0.06. What is the ratio of the Expenses (in $) of Grants and Revenue in 1998 to that in 2009?
Give a very brief answer. 0. What is the ratio of the Expenses (in $) in Services in 1998 to that in 2009?
Your answer should be compact. 0.2. What is the ratio of the Expenses (in $) of Miscellaneous expenses in 1998 to that in 2010?
Keep it short and to the point. 0.01. What is the ratio of the Expenses (in $) in Labor Taxes in 1998 to that in 2010?
Make the answer very short. 0.09. What is the ratio of the Expenses (in $) in Grants and Revenue in 1998 to that in 2010?
Your answer should be compact. 0. What is the ratio of the Expenses (in $) in Services in 1998 to that in 2010?
Provide a short and direct response. 0.18. What is the ratio of the Expenses (in $) of Miscellaneous expenses in 1998 to that in 2011?
Offer a terse response. 0.01. What is the ratio of the Expenses (in $) of Labor Taxes in 1998 to that in 2011?
Offer a terse response. 0.06. What is the ratio of the Expenses (in $) in Grants and Revenue in 1998 to that in 2011?
Offer a terse response. 0. What is the ratio of the Expenses (in $) in Services in 1998 to that in 2011?
Provide a short and direct response. 0.17. What is the ratio of the Expenses (in $) of Miscellaneous expenses in 1998 to that in 2012?
Your response must be concise. 0. What is the ratio of the Expenses (in $) of Labor Taxes in 1998 to that in 2012?
Make the answer very short. 0.04. What is the ratio of the Expenses (in $) of Grants and Revenue in 1998 to that in 2012?
Give a very brief answer. 0. What is the ratio of the Expenses (in $) in Services in 1998 to that in 2012?
Your answer should be compact. 0.12. What is the ratio of the Expenses (in $) in Miscellaneous expenses in 1999 to that in 2008?
Offer a very short reply. 0. What is the ratio of the Expenses (in $) in Labor Taxes in 1999 to that in 2008?
Your response must be concise. 1.17. What is the ratio of the Expenses (in $) in Grants and Revenue in 1999 to that in 2008?
Your response must be concise. 0.98. What is the ratio of the Expenses (in $) of Services in 1999 to that in 2008?
Keep it short and to the point. 0.27. What is the ratio of the Expenses (in $) of Miscellaneous expenses in 1999 to that in 2009?
Ensure brevity in your answer.  0. What is the ratio of the Expenses (in $) of Labor Taxes in 1999 to that in 2009?
Your answer should be compact. 0.11. What is the ratio of the Expenses (in $) in Grants and Revenue in 1999 to that in 2009?
Offer a terse response. 0. What is the ratio of the Expenses (in $) of Services in 1999 to that in 2009?
Give a very brief answer. 0.23. What is the ratio of the Expenses (in $) of Miscellaneous expenses in 1999 to that in 2010?
Offer a terse response. 0. What is the ratio of the Expenses (in $) of Labor Taxes in 1999 to that in 2010?
Provide a short and direct response. 0.16. What is the ratio of the Expenses (in $) in Grants and Revenue in 1999 to that in 2010?
Give a very brief answer. 0.01. What is the ratio of the Expenses (in $) in Services in 1999 to that in 2010?
Make the answer very short. 0.21. What is the ratio of the Expenses (in $) of Miscellaneous expenses in 1999 to that in 2011?
Make the answer very short. 0. What is the ratio of the Expenses (in $) of Labor Taxes in 1999 to that in 2011?
Give a very brief answer. 0.11. What is the ratio of the Expenses (in $) in Grants and Revenue in 1999 to that in 2011?
Your response must be concise. 0. What is the ratio of the Expenses (in $) of Services in 1999 to that in 2011?
Your answer should be compact. 0.2. What is the ratio of the Expenses (in $) in Miscellaneous expenses in 1999 to that in 2012?
Provide a short and direct response. 0. What is the ratio of the Expenses (in $) of Labor Taxes in 1999 to that in 2012?
Your answer should be very brief. 0.08. What is the ratio of the Expenses (in $) of Grants and Revenue in 1999 to that in 2012?
Your response must be concise. 0. What is the ratio of the Expenses (in $) in Services in 1999 to that in 2012?
Your answer should be very brief. 0.14. What is the ratio of the Expenses (in $) of Labor Taxes in 2008 to that in 2009?
Make the answer very short. 0.09. What is the ratio of the Expenses (in $) of Grants and Revenue in 2008 to that in 2009?
Make the answer very short. 0. What is the ratio of the Expenses (in $) of Services in 2008 to that in 2009?
Make the answer very short. 0.86. What is the ratio of the Expenses (in $) of Miscellaneous expenses in 2008 to that in 2010?
Keep it short and to the point. 0.87. What is the ratio of the Expenses (in $) of Labor Taxes in 2008 to that in 2010?
Ensure brevity in your answer.  0.14. What is the ratio of the Expenses (in $) of Grants and Revenue in 2008 to that in 2010?
Offer a very short reply. 0.01. What is the ratio of the Expenses (in $) of Services in 2008 to that in 2010?
Give a very brief answer. 0.79. What is the ratio of the Expenses (in $) of Miscellaneous expenses in 2008 to that in 2011?
Provide a short and direct response. 0.89. What is the ratio of the Expenses (in $) of Labor Taxes in 2008 to that in 2011?
Give a very brief answer. 0.09. What is the ratio of the Expenses (in $) in Grants and Revenue in 2008 to that in 2011?
Provide a short and direct response. 0. What is the ratio of the Expenses (in $) in Services in 2008 to that in 2011?
Keep it short and to the point. 0.73. What is the ratio of the Expenses (in $) of Miscellaneous expenses in 2008 to that in 2012?
Your response must be concise. 0.59. What is the ratio of the Expenses (in $) of Labor Taxes in 2008 to that in 2012?
Your response must be concise. 0.07. What is the ratio of the Expenses (in $) in Grants and Revenue in 2008 to that in 2012?
Ensure brevity in your answer.  0. What is the ratio of the Expenses (in $) in Services in 2008 to that in 2012?
Provide a succinct answer. 0.52. What is the ratio of the Expenses (in $) in Miscellaneous expenses in 2009 to that in 2010?
Offer a terse response. 0.87. What is the ratio of the Expenses (in $) in Labor Taxes in 2009 to that in 2010?
Your response must be concise. 1.5. What is the ratio of the Expenses (in $) in Grants and Revenue in 2009 to that in 2010?
Keep it short and to the point. 1.43. What is the ratio of the Expenses (in $) of Services in 2009 to that in 2010?
Give a very brief answer. 0.92. What is the ratio of the Expenses (in $) in Miscellaneous expenses in 2009 to that in 2011?
Give a very brief answer. 0.9. What is the ratio of the Expenses (in $) in Labor Taxes in 2009 to that in 2011?
Ensure brevity in your answer.  1.01. What is the ratio of the Expenses (in $) in Grants and Revenue in 2009 to that in 2011?
Your response must be concise. 0.9. What is the ratio of the Expenses (in $) in Services in 2009 to that in 2011?
Your response must be concise. 0.84. What is the ratio of the Expenses (in $) of Miscellaneous expenses in 2009 to that in 2012?
Make the answer very short. 0.59. What is the ratio of the Expenses (in $) of Labor Taxes in 2009 to that in 2012?
Provide a short and direct response. 0.72. What is the ratio of the Expenses (in $) of Grants and Revenue in 2009 to that in 2012?
Your response must be concise. 0.76. What is the ratio of the Expenses (in $) in Services in 2009 to that in 2012?
Offer a terse response. 0.6. What is the ratio of the Expenses (in $) of Miscellaneous expenses in 2010 to that in 2011?
Ensure brevity in your answer.  1.02. What is the ratio of the Expenses (in $) in Labor Taxes in 2010 to that in 2011?
Your answer should be very brief. 0.67. What is the ratio of the Expenses (in $) of Grants and Revenue in 2010 to that in 2011?
Make the answer very short. 0.63. What is the ratio of the Expenses (in $) in Services in 2010 to that in 2011?
Give a very brief answer. 0.92. What is the ratio of the Expenses (in $) of Miscellaneous expenses in 2010 to that in 2012?
Offer a very short reply. 0.67. What is the ratio of the Expenses (in $) of Labor Taxes in 2010 to that in 2012?
Offer a very short reply. 0.48. What is the ratio of the Expenses (in $) of Grants and Revenue in 2010 to that in 2012?
Make the answer very short. 0.53. What is the ratio of the Expenses (in $) in Services in 2010 to that in 2012?
Make the answer very short. 0.66. What is the ratio of the Expenses (in $) of Miscellaneous expenses in 2011 to that in 2012?
Make the answer very short. 0.66. What is the ratio of the Expenses (in $) of Labor Taxes in 2011 to that in 2012?
Offer a very short reply. 0.72. What is the ratio of the Expenses (in $) in Grants and Revenue in 2011 to that in 2012?
Provide a short and direct response. 0.85. What is the ratio of the Expenses (in $) of Services in 2011 to that in 2012?
Your answer should be very brief. 0.71. What is the difference between the highest and the second highest Expenses (in $) of Miscellaneous expenses?
Offer a very short reply. 1.57e+09. What is the difference between the highest and the second highest Expenses (in $) in Labor Taxes?
Provide a succinct answer. 5.88e+07. What is the difference between the highest and the second highest Expenses (in $) in Grants and Revenue?
Ensure brevity in your answer.  2.48e+09. What is the difference between the highest and the second highest Expenses (in $) of Services?
Provide a short and direct response. 3.76e+08. What is the difference between the highest and the lowest Expenses (in $) in Miscellaneous expenses?
Provide a short and direct response. 4.79e+09. What is the difference between the highest and the lowest Expenses (in $) of Labor Taxes?
Offer a terse response. 2.02e+08. What is the difference between the highest and the lowest Expenses (in $) of Grants and Revenue?
Your response must be concise. 1.61e+1. What is the difference between the highest and the lowest Expenses (in $) in Services?
Keep it short and to the point. 1.16e+09. 